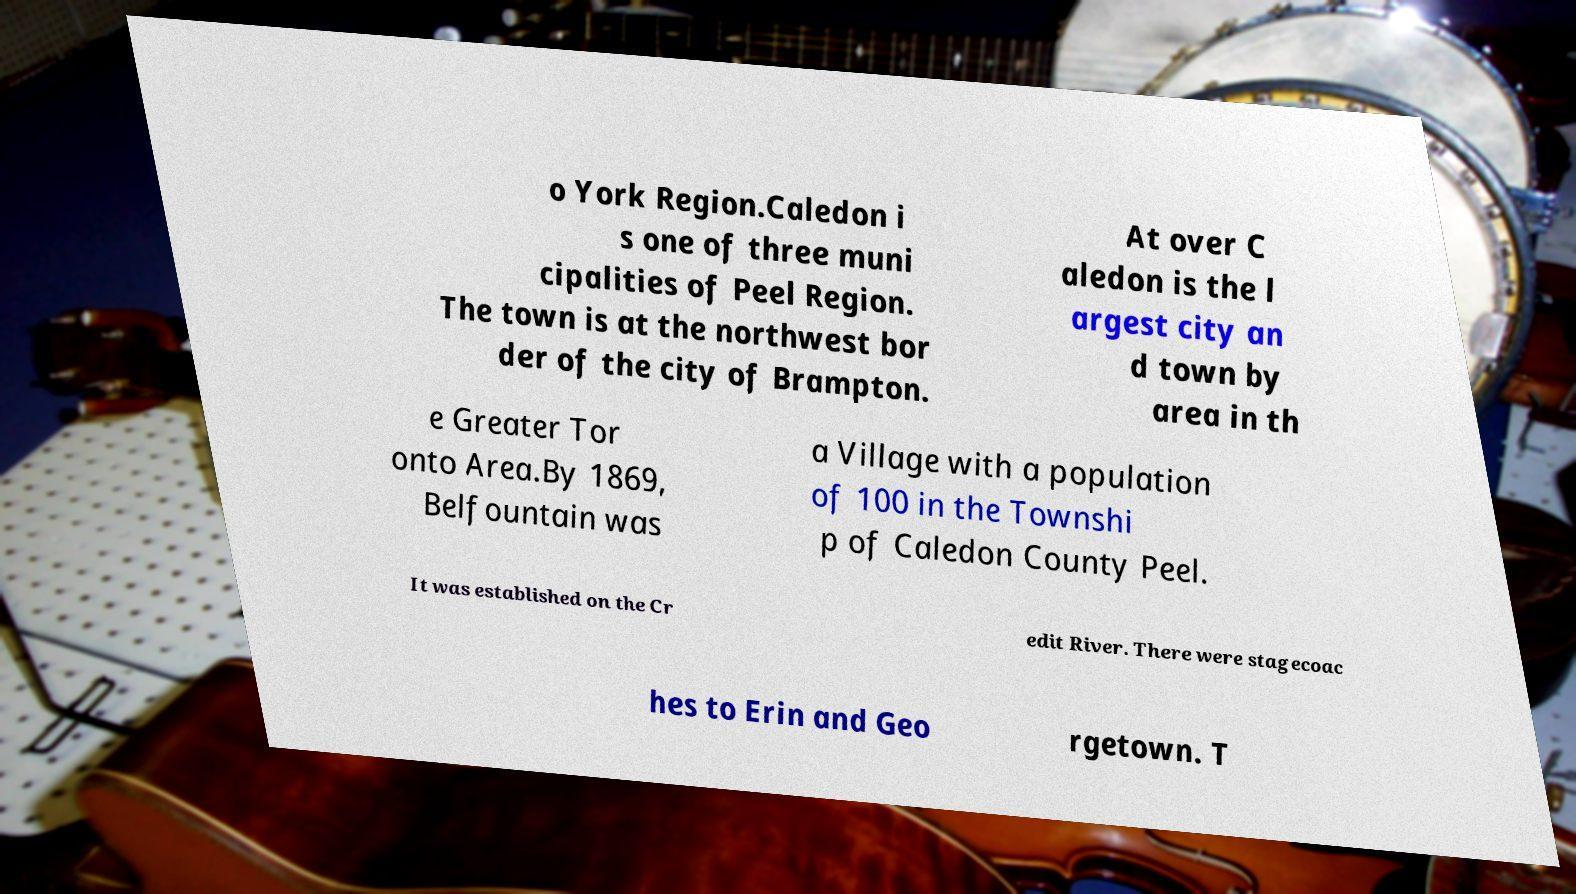I need the written content from this picture converted into text. Can you do that? o York Region.Caledon i s one of three muni cipalities of Peel Region. The town is at the northwest bor der of the city of Brampton. At over C aledon is the l argest city an d town by area in th e Greater Tor onto Area.By 1869, Belfountain was a Village with a population of 100 in the Townshi p of Caledon County Peel. It was established on the Cr edit River. There were stagecoac hes to Erin and Geo rgetown. T 